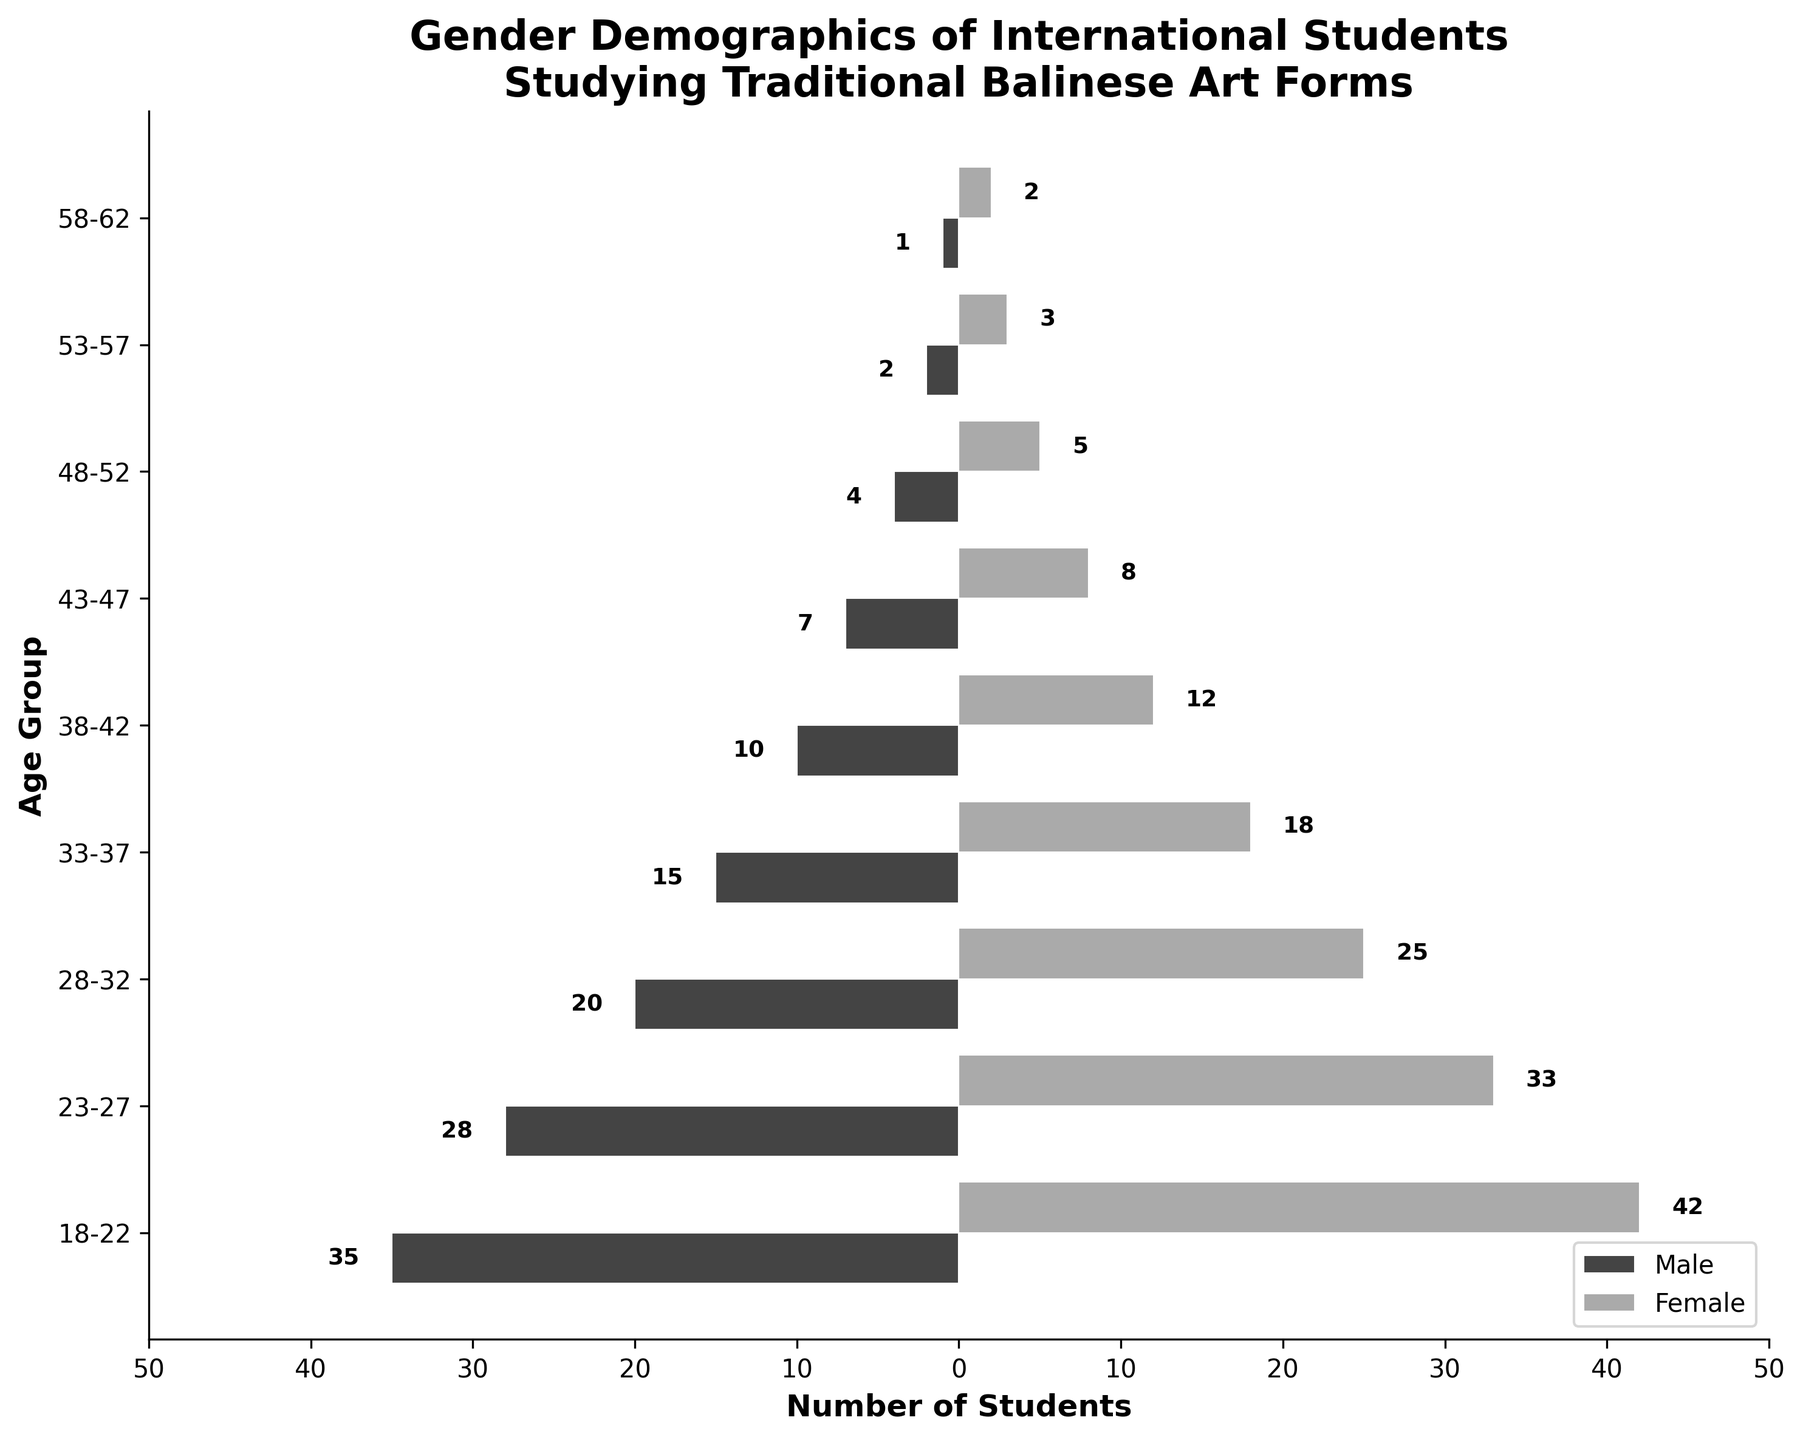What is the title of the figure? The title is typically placed at the top of the figure and provides a brief description of the data being presented.
Answer: Gender Demographics of International Students Studying Traditional Balinese Art Forms What is the age group with the highest number of female students? To find the age group with the highest number of female students, compare the values on the right side of the figure (Female). The largest female bar represents the 18-22 age group with 42 students.
Answer: 18-22 What is the total number of international students in the 23-27 age group? Summing the number of male and female students in the 23-27 age group (28 males + 33 females) gives 61 students.
Answer: 61 What is the difference in the number of male and female students aged 33-37? Subtract the number of male students from the number of female students in the 33-37 age group (18 females - 15 males) to get a difference of 3 students.
Answer: 3 Which gender has more students in the 48-52 age group, and by how much? Compare the number of male and female students in the 48-52 age group (5 females - 4 males) to find that there is 1 more female student.
Answer: Female by 1 In which age group is the gender ratio (number of males to females) closest to 1:1? A 1:1 ratio means that the numbers of males and females are nearly equal. In the 43-47 age group, there are 7 males and 8 females, which is the closest ratio to 1:1.
Answer: 43-47 How does the number of male students aged 18-22 compare to the number of male students aged 28-32? Compare the number of male students in the 18-22 age group (35) with the 28-32 age group (20) to find that there are 15 more male students in the 18-22 age group.
Answer: 15 more in 18-22 What is the total number of students aged 38-42? Add the number of male and female students in the 38-42 age group (10 males + 12 females) to get a total of 22 students.
Answer: 22 Which age group has the fewest number of male students? The age group with the smallest bar on the left side of the chart (Male) represents the 58-62 age group, which has 1 male student.
Answer: 58-62 What is the sum of male and female students in the youngest age group provided? Sum the number of male and female students in the 18-22 age group (35 males + 42 females) to find the total of 77 students.
Answer: 77 